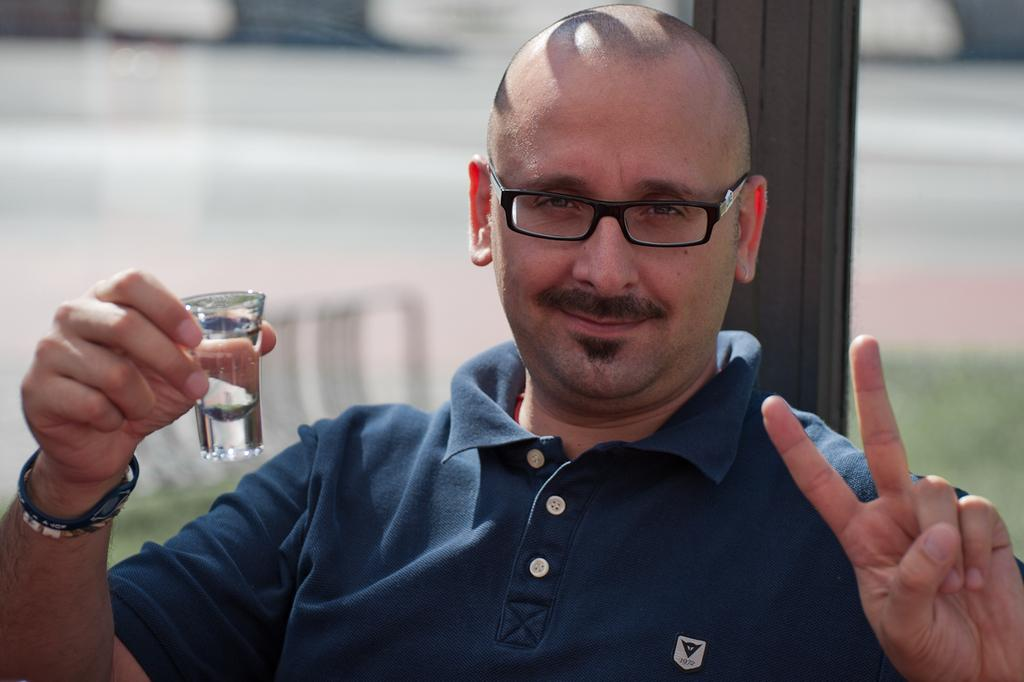What is the appearance of the man's hair in the image? The man in the image is bald-headed. What color is the t-shirt the man is wearing? The man is wearing a navy blue t-shirt. What is the man holding in the image? The man is holding a peace symbol. What is the man standing in front of in the image? The man is standing in front of a pole. How would you describe the background of the image? The background of the image is blurry. What type of lace is draped over the man's arm in the image? There is no lace present in the image; the man is holding a peace symbol and standing in front of a pole. 